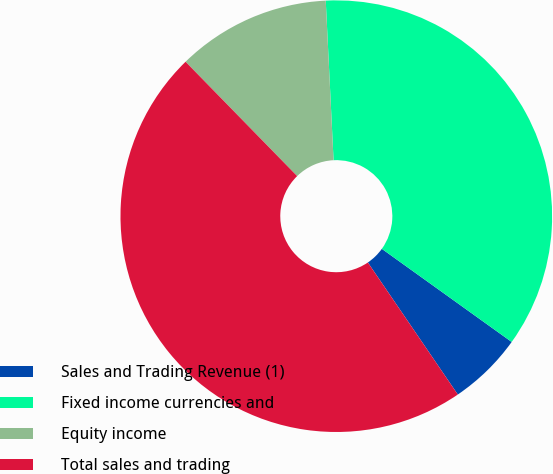Convert chart. <chart><loc_0><loc_0><loc_500><loc_500><pie_chart><fcel>Sales and Trading Revenue (1)<fcel>Fixed income currencies and<fcel>Equity income<fcel>Total sales and trading<nl><fcel>5.58%<fcel>35.68%<fcel>11.53%<fcel>47.21%<nl></chart> 